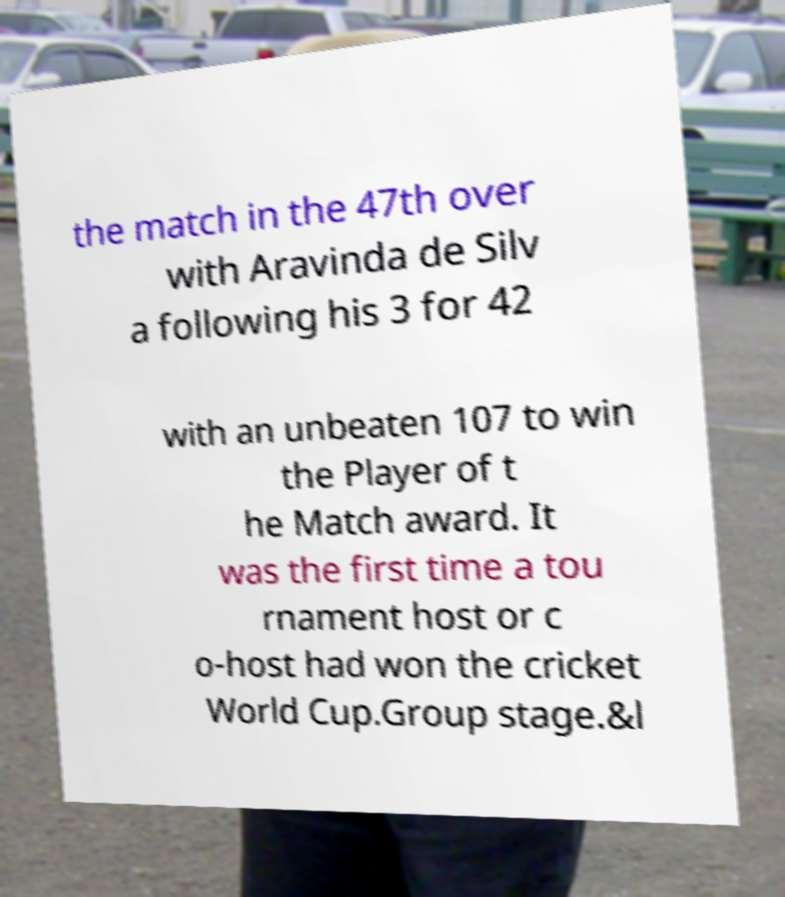What messages or text are displayed in this image? I need them in a readable, typed format. the match in the 47th over with Aravinda de Silv a following his 3 for 42 with an unbeaten 107 to win the Player of t he Match award. It was the first time a tou rnament host or c o-host had won the cricket World Cup.Group stage.&l 